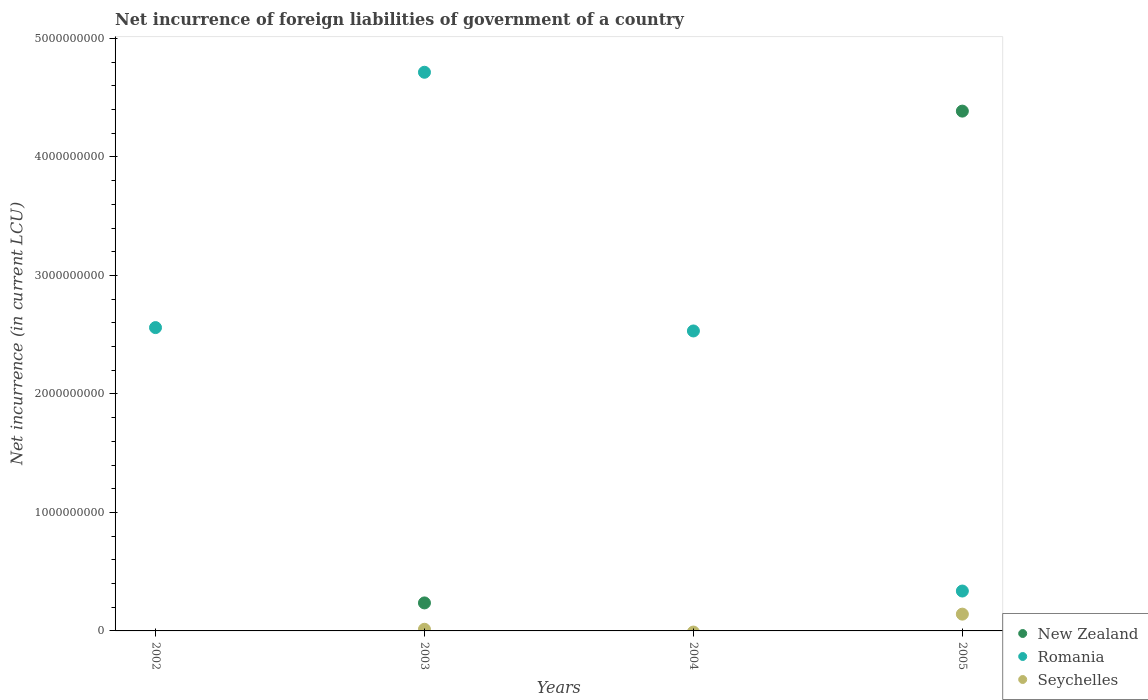How many different coloured dotlines are there?
Make the answer very short. 3. Is the number of dotlines equal to the number of legend labels?
Your answer should be very brief. No. Across all years, what is the maximum net incurrence of foreign liabilities in Seychelles?
Your answer should be compact. 1.42e+08. Across all years, what is the minimum net incurrence of foreign liabilities in New Zealand?
Your answer should be very brief. 0. In which year was the net incurrence of foreign liabilities in Romania maximum?
Offer a very short reply. 2003. What is the total net incurrence of foreign liabilities in Seychelles in the graph?
Ensure brevity in your answer.  1.56e+08. What is the difference between the net incurrence of foreign liabilities in Romania in 2004 and that in 2005?
Ensure brevity in your answer.  2.19e+09. What is the difference between the net incurrence of foreign liabilities in Romania in 2003 and the net incurrence of foreign liabilities in New Zealand in 2005?
Offer a very short reply. 3.28e+08. What is the average net incurrence of foreign liabilities in Romania per year?
Your response must be concise. 2.54e+09. In the year 2003, what is the difference between the net incurrence of foreign liabilities in Romania and net incurrence of foreign liabilities in Seychelles?
Your answer should be compact. 4.70e+09. In how many years, is the net incurrence of foreign liabilities in Romania greater than 400000000 LCU?
Your answer should be very brief. 3. What is the ratio of the net incurrence of foreign liabilities in Romania in 2002 to that in 2004?
Make the answer very short. 1.01. Is the difference between the net incurrence of foreign liabilities in Romania in 2003 and 2005 greater than the difference between the net incurrence of foreign liabilities in Seychelles in 2003 and 2005?
Your response must be concise. Yes. What is the difference between the highest and the second highest net incurrence of foreign liabilities in Romania?
Provide a short and direct response. 2.15e+09. What is the difference between the highest and the lowest net incurrence of foreign liabilities in Seychelles?
Keep it short and to the point. 1.42e+08. In how many years, is the net incurrence of foreign liabilities in New Zealand greater than the average net incurrence of foreign liabilities in New Zealand taken over all years?
Your answer should be very brief. 1. Does the net incurrence of foreign liabilities in New Zealand monotonically increase over the years?
Ensure brevity in your answer.  No. Is the net incurrence of foreign liabilities in New Zealand strictly greater than the net incurrence of foreign liabilities in Seychelles over the years?
Provide a short and direct response. No. Is the net incurrence of foreign liabilities in Romania strictly less than the net incurrence of foreign liabilities in Seychelles over the years?
Keep it short and to the point. No. How many dotlines are there?
Your response must be concise. 3. How many years are there in the graph?
Provide a short and direct response. 4. Does the graph contain any zero values?
Make the answer very short. Yes. Does the graph contain grids?
Provide a succinct answer. No. How are the legend labels stacked?
Provide a short and direct response. Vertical. What is the title of the graph?
Your response must be concise. Net incurrence of foreign liabilities of government of a country. Does "Hong Kong" appear as one of the legend labels in the graph?
Give a very brief answer. No. What is the label or title of the X-axis?
Give a very brief answer. Years. What is the label or title of the Y-axis?
Your answer should be compact. Net incurrence (in current LCU). What is the Net incurrence (in current LCU) in Romania in 2002?
Offer a terse response. 2.56e+09. What is the Net incurrence (in current LCU) of New Zealand in 2003?
Your answer should be very brief. 2.36e+08. What is the Net incurrence (in current LCU) in Romania in 2003?
Offer a terse response. 4.71e+09. What is the Net incurrence (in current LCU) of Seychelles in 2003?
Offer a very short reply. 1.39e+07. What is the Net incurrence (in current LCU) in Romania in 2004?
Offer a terse response. 2.53e+09. What is the Net incurrence (in current LCU) in New Zealand in 2005?
Your answer should be compact. 4.39e+09. What is the Net incurrence (in current LCU) of Romania in 2005?
Give a very brief answer. 3.37e+08. What is the Net incurrence (in current LCU) in Seychelles in 2005?
Make the answer very short. 1.42e+08. Across all years, what is the maximum Net incurrence (in current LCU) in New Zealand?
Provide a short and direct response. 4.39e+09. Across all years, what is the maximum Net incurrence (in current LCU) in Romania?
Ensure brevity in your answer.  4.71e+09. Across all years, what is the maximum Net incurrence (in current LCU) of Seychelles?
Your response must be concise. 1.42e+08. Across all years, what is the minimum Net incurrence (in current LCU) in Romania?
Your answer should be compact. 3.37e+08. What is the total Net incurrence (in current LCU) of New Zealand in the graph?
Ensure brevity in your answer.  4.62e+09. What is the total Net incurrence (in current LCU) of Romania in the graph?
Your answer should be very brief. 1.01e+1. What is the total Net incurrence (in current LCU) of Seychelles in the graph?
Provide a short and direct response. 1.56e+08. What is the difference between the Net incurrence (in current LCU) in Romania in 2002 and that in 2003?
Provide a short and direct response. -2.15e+09. What is the difference between the Net incurrence (in current LCU) in Romania in 2002 and that in 2004?
Provide a short and direct response. 2.83e+07. What is the difference between the Net incurrence (in current LCU) of Romania in 2002 and that in 2005?
Make the answer very short. 2.22e+09. What is the difference between the Net incurrence (in current LCU) in Romania in 2003 and that in 2004?
Ensure brevity in your answer.  2.18e+09. What is the difference between the Net incurrence (in current LCU) in New Zealand in 2003 and that in 2005?
Offer a very short reply. -4.15e+09. What is the difference between the Net incurrence (in current LCU) of Romania in 2003 and that in 2005?
Provide a short and direct response. 4.38e+09. What is the difference between the Net incurrence (in current LCU) in Seychelles in 2003 and that in 2005?
Your answer should be very brief. -1.28e+08. What is the difference between the Net incurrence (in current LCU) in Romania in 2004 and that in 2005?
Your answer should be very brief. 2.19e+09. What is the difference between the Net incurrence (in current LCU) in Romania in 2002 and the Net incurrence (in current LCU) in Seychelles in 2003?
Offer a terse response. 2.55e+09. What is the difference between the Net incurrence (in current LCU) of Romania in 2002 and the Net incurrence (in current LCU) of Seychelles in 2005?
Your answer should be very brief. 2.42e+09. What is the difference between the Net incurrence (in current LCU) in New Zealand in 2003 and the Net incurrence (in current LCU) in Romania in 2004?
Offer a very short reply. -2.29e+09. What is the difference between the Net incurrence (in current LCU) of New Zealand in 2003 and the Net incurrence (in current LCU) of Romania in 2005?
Your answer should be very brief. -1.00e+08. What is the difference between the Net incurrence (in current LCU) of New Zealand in 2003 and the Net incurrence (in current LCU) of Seychelles in 2005?
Ensure brevity in your answer.  9.47e+07. What is the difference between the Net incurrence (in current LCU) in Romania in 2003 and the Net incurrence (in current LCU) in Seychelles in 2005?
Make the answer very short. 4.57e+09. What is the difference between the Net incurrence (in current LCU) in Romania in 2004 and the Net incurrence (in current LCU) in Seychelles in 2005?
Provide a succinct answer. 2.39e+09. What is the average Net incurrence (in current LCU) in New Zealand per year?
Offer a terse response. 1.16e+09. What is the average Net incurrence (in current LCU) in Romania per year?
Make the answer very short. 2.54e+09. What is the average Net incurrence (in current LCU) in Seychelles per year?
Your answer should be compact. 3.89e+07. In the year 2003, what is the difference between the Net incurrence (in current LCU) in New Zealand and Net incurrence (in current LCU) in Romania?
Your response must be concise. -4.48e+09. In the year 2003, what is the difference between the Net incurrence (in current LCU) of New Zealand and Net incurrence (in current LCU) of Seychelles?
Offer a terse response. 2.22e+08. In the year 2003, what is the difference between the Net incurrence (in current LCU) of Romania and Net incurrence (in current LCU) of Seychelles?
Make the answer very short. 4.70e+09. In the year 2005, what is the difference between the Net incurrence (in current LCU) of New Zealand and Net incurrence (in current LCU) of Romania?
Your answer should be very brief. 4.05e+09. In the year 2005, what is the difference between the Net incurrence (in current LCU) in New Zealand and Net incurrence (in current LCU) in Seychelles?
Provide a succinct answer. 4.24e+09. In the year 2005, what is the difference between the Net incurrence (in current LCU) in Romania and Net incurrence (in current LCU) in Seychelles?
Ensure brevity in your answer.  1.95e+08. What is the ratio of the Net incurrence (in current LCU) in Romania in 2002 to that in 2003?
Ensure brevity in your answer.  0.54. What is the ratio of the Net incurrence (in current LCU) of Romania in 2002 to that in 2004?
Your answer should be very brief. 1.01. What is the ratio of the Net incurrence (in current LCU) of Romania in 2002 to that in 2005?
Provide a short and direct response. 7.6. What is the ratio of the Net incurrence (in current LCU) of Romania in 2003 to that in 2004?
Your answer should be very brief. 1.86. What is the ratio of the Net incurrence (in current LCU) of New Zealand in 2003 to that in 2005?
Provide a succinct answer. 0.05. What is the ratio of the Net incurrence (in current LCU) of Romania in 2003 to that in 2005?
Your answer should be compact. 14.01. What is the ratio of the Net incurrence (in current LCU) in Seychelles in 2003 to that in 2005?
Make the answer very short. 0.1. What is the ratio of the Net incurrence (in current LCU) of Romania in 2004 to that in 2005?
Make the answer very short. 7.52. What is the difference between the highest and the second highest Net incurrence (in current LCU) of Romania?
Ensure brevity in your answer.  2.15e+09. What is the difference between the highest and the lowest Net incurrence (in current LCU) of New Zealand?
Make the answer very short. 4.39e+09. What is the difference between the highest and the lowest Net incurrence (in current LCU) in Romania?
Provide a succinct answer. 4.38e+09. What is the difference between the highest and the lowest Net incurrence (in current LCU) in Seychelles?
Your answer should be compact. 1.42e+08. 